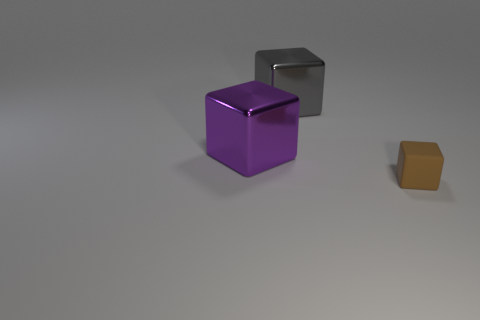Is there any other thing that has the same size as the brown cube?
Offer a terse response. No. Does the gray cube have the same size as the rubber thing?
Make the answer very short. No. Is the big purple thing the same shape as the small brown object?
Make the answer very short. Yes. Is there any other thing that is the same shape as the big gray metal object?
Your response must be concise. Yes. Is the big cube to the right of the purple shiny cube made of the same material as the small cube?
Provide a succinct answer. No. The thing that is on the right side of the big purple shiny object and behind the rubber block has what shape?
Your answer should be compact. Cube. There is a metal block that is to the left of the gray metal block; are there any metal cubes behind it?
Offer a terse response. Yes. How many other objects are the same material as the brown cube?
Your answer should be compact. 0. There is a object to the left of the large gray thing; is it the same shape as the thing that is to the right of the big gray thing?
Offer a very short reply. Yes. Is the material of the brown cube the same as the large gray block?
Keep it short and to the point. No. 